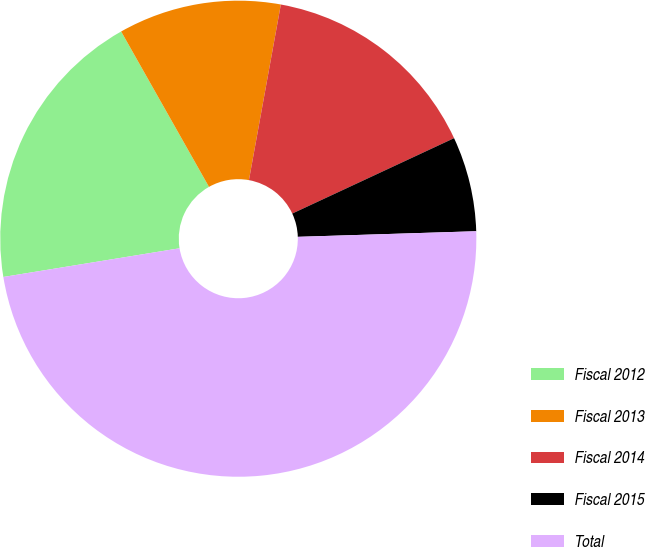<chart> <loc_0><loc_0><loc_500><loc_500><pie_chart><fcel>Fiscal 2012<fcel>Fiscal 2013<fcel>Fiscal 2014<fcel>Fiscal 2015<fcel>Total<nl><fcel>19.38%<fcel>11.05%<fcel>15.2%<fcel>6.44%<fcel>47.93%<nl></chart> 